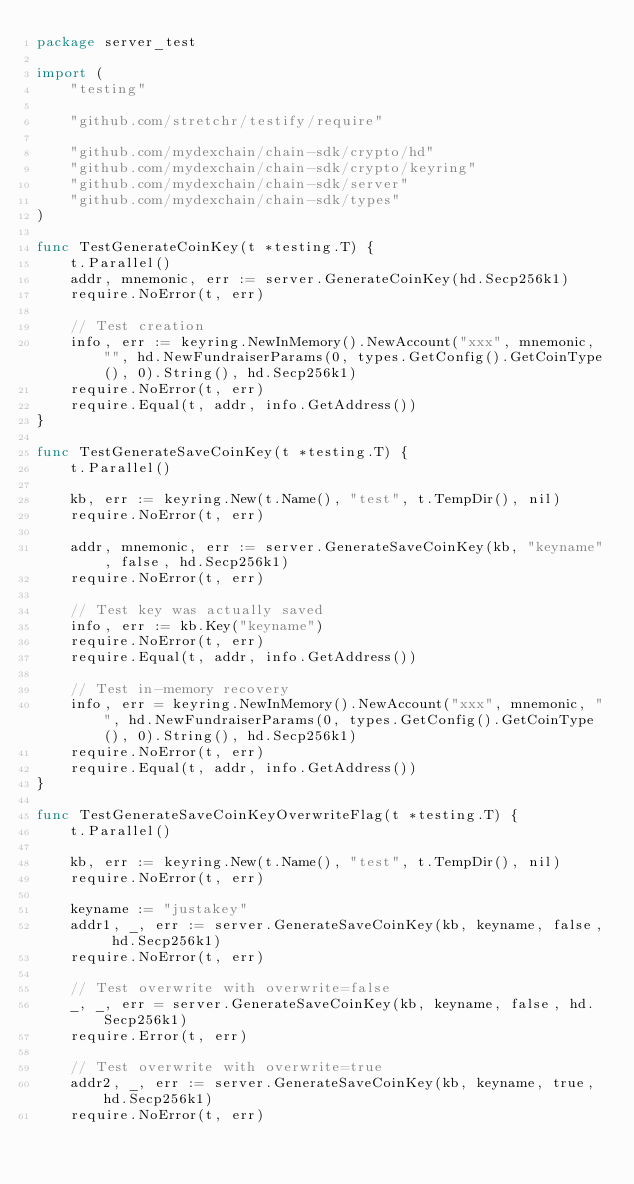Convert code to text. <code><loc_0><loc_0><loc_500><loc_500><_Go_>package server_test

import (
	"testing"

	"github.com/stretchr/testify/require"

	"github.com/mydexchain/chain-sdk/crypto/hd"
	"github.com/mydexchain/chain-sdk/crypto/keyring"
	"github.com/mydexchain/chain-sdk/server"
	"github.com/mydexchain/chain-sdk/types"
)

func TestGenerateCoinKey(t *testing.T) {
	t.Parallel()
	addr, mnemonic, err := server.GenerateCoinKey(hd.Secp256k1)
	require.NoError(t, err)

	// Test creation
	info, err := keyring.NewInMemory().NewAccount("xxx", mnemonic, "", hd.NewFundraiserParams(0, types.GetConfig().GetCoinType(), 0).String(), hd.Secp256k1)
	require.NoError(t, err)
	require.Equal(t, addr, info.GetAddress())
}

func TestGenerateSaveCoinKey(t *testing.T) {
	t.Parallel()

	kb, err := keyring.New(t.Name(), "test", t.TempDir(), nil)
	require.NoError(t, err)

	addr, mnemonic, err := server.GenerateSaveCoinKey(kb, "keyname", false, hd.Secp256k1)
	require.NoError(t, err)

	// Test key was actually saved
	info, err := kb.Key("keyname")
	require.NoError(t, err)
	require.Equal(t, addr, info.GetAddress())

	// Test in-memory recovery
	info, err = keyring.NewInMemory().NewAccount("xxx", mnemonic, "", hd.NewFundraiserParams(0, types.GetConfig().GetCoinType(), 0).String(), hd.Secp256k1)
	require.NoError(t, err)
	require.Equal(t, addr, info.GetAddress())
}

func TestGenerateSaveCoinKeyOverwriteFlag(t *testing.T) {
	t.Parallel()

	kb, err := keyring.New(t.Name(), "test", t.TempDir(), nil)
	require.NoError(t, err)

	keyname := "justakey"
	addr1, _, err := server.GenerateSaveCoinKey(kb, keyname, false, hd.Secp256k1)
	require.NoError(t, err)

	// Test overwrite with overwrite=false
	_, _, err = server.GenerateSaveCoinKey(kb, keyname, false, hd.Secp256k1)
	require.Error(t, err)

	// Test overwrite with overwrite=true
	addr2, _, err := server.GenerateSaveCoinKey(kb, keyname, true, hd.Secp256k1)
	require.NoError(t, err)
</code> 